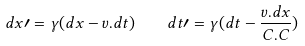<formula> <loc_0><loc_0><loc_500><loc_500>d x \prime = \gamma ( d x - v . d t ) \, \quad d t \prime = \gamma ( d t - \frac { v . d x } { C . C } ) \,</formula> 